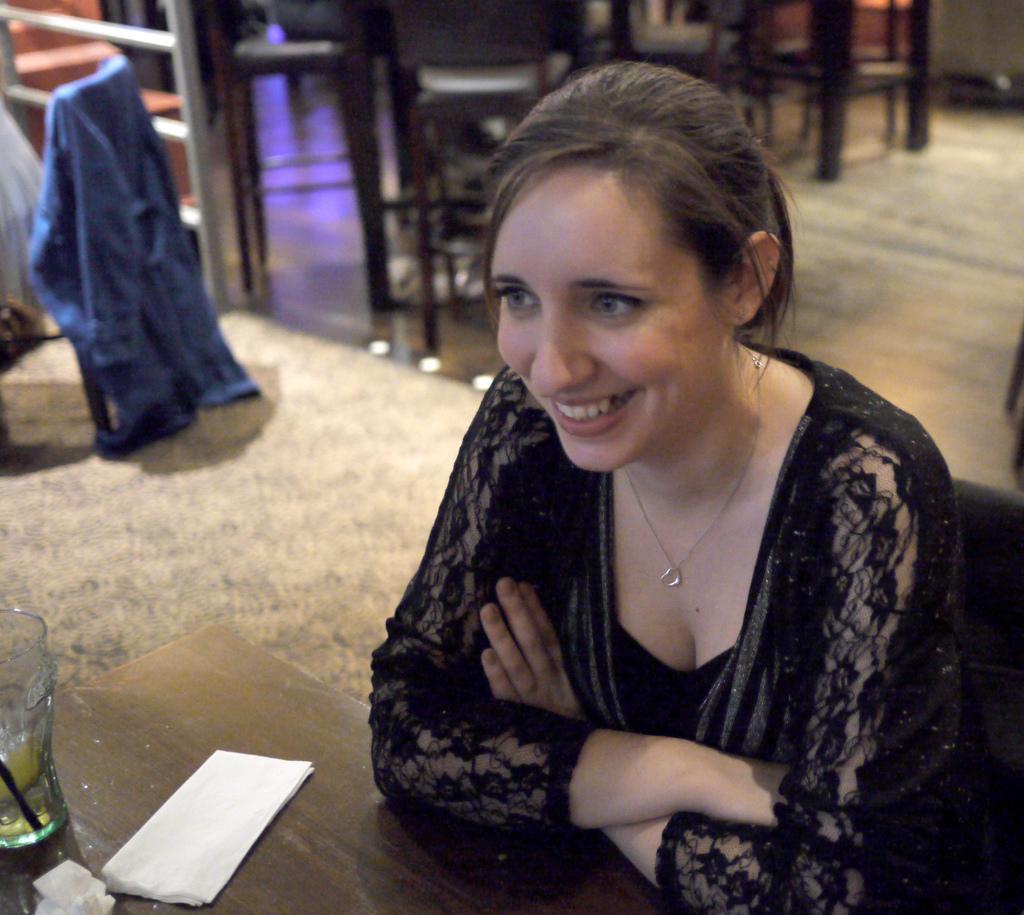How would you summarize this image in a sentence or two? This is the woman sitting on the chair and smiling. Here is the wooden table. I can see a glass and tissue papers placed on it. This looks like a cloth, which is blue in color. In the background, I can see the chairs. 